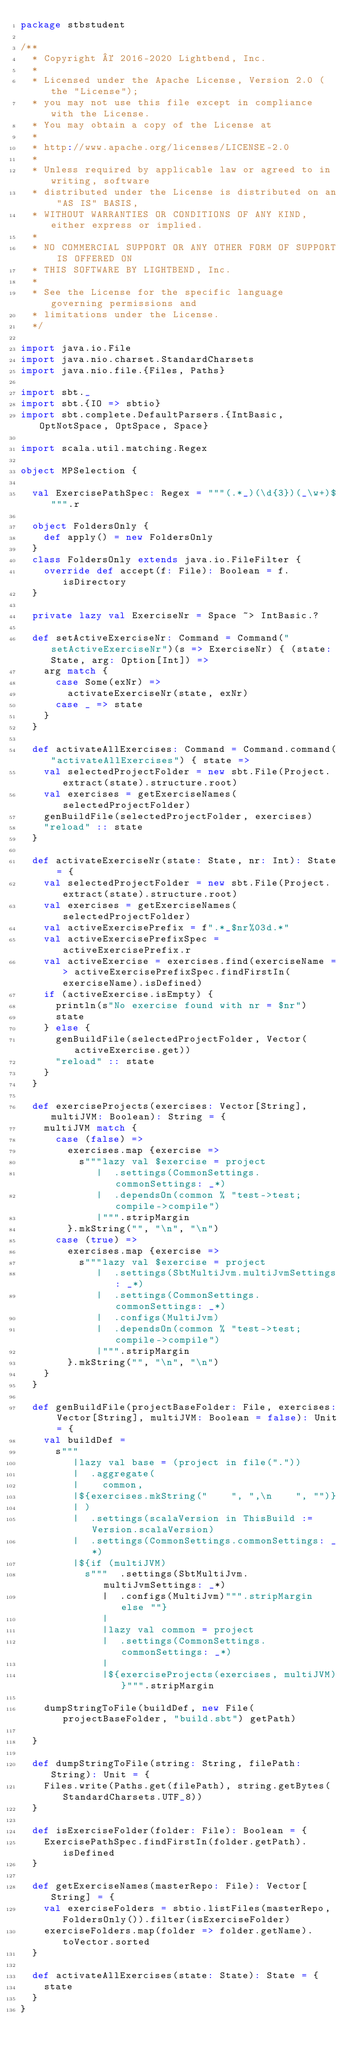<code> <loc_0><loc_0><loc_500><loc_500><_Scala_>package stbstudent

/**
  * Copyright © 2016-2020 Lightbend, Inc.
  *
  * Licensed under the Apache License, Version 2.0 (the "License");
  * you may not use this file except in compliance with the License.
  * You may obtain a copy of the License at
  *
  * http://www.apache.org/licenses/LICENSE-2.0
  *
  * Unless required by applicable law or agreed to in writing, software
  * distributed under the License is distributed on an "AS IS" BASIS,
  * WITHOUT WARRANTIES OR CONDITIONS OF ANY KIND, either express or implied.
  *
  * NO COMMERCIAL SUPPORT OR ANY OTHER FORM OF SUPPORT IS OFFERED ON
  * THIS SOFTWARE BY LIGHTBEND, Inc.
  *
  * See the License for the specific language governing permissions and
  * limitations under the License.
  */

import java.io.File
import java.nio.charset.StandardCharsets
import java.nio.file.{Files, Paths}

import sbt._
import sbt.{IO => sbtio}
import sbt.complete.DefaultParsers.{IntBasic, OptNotSpace, OptSpace, Space}

import scala.util.matching.Regex

object MPSelection {

  val ExercisePathSpec: Regex = """(.*_)(\d{3})(_\w+)$""".r

  object FoldersOnly {
    def apply() = new FoldersOnly
  }
  class FoldersOnly extends java.io.FileFilter {
    override def accept(f: File): Boolean = f.isDirectory
  }

  private lazy val ExerciseNr = Space ~> IntBasic.?

  def setActiveExerciseNr: Command = Command("setActiveExerciseNr")(s => ExerciseNr) { (state: State, arg: Option[Int]) =>
    arg match {
      case Some(exNr) =>
        activateExerciseNr(state, exNr)
      case _ => state
    }
  }

  def activateAllExercises: Command = Command.command("activateAllExercises") { state =>
    val selectedProjectFolder = new sbt.File(Project.extract(state).structure.root)
    val exercises = getExerciseNames(selectedProjectFolder)
    genBuildFile(selectedProjectFolder, exercises)
    "reload" :: state
  }

  def activateExerciseNr(state: State, nr: Int): State = {
    val selectedProjectFolder = new sbt.File(Project.extract(state).structure.root)
    val exercises = getExerciseNames(selectedProjectFolder)
    val activeExercisePrefix = f".*_$nr%03d.*"
    val activeExercisePrefixSpec = activeExercisePrefix.r
    val activeExercise = exercises.find(exerciseName => activeExercisePrefixSpec.findFirstIn(exerciseName).isDefined)
    if (activeExercise.isEmpty) {
      println(s"No exercise found with nr = $nr")
      state
    } else {
      genBuildFile(selectedProjectFolder, Vector(activeExercise.get))
      "reload" :: state
    }
  }

  def exerciseProjects(exercises: Vector[String], multiJVM: Boolean): String = {
    multiJVM match {
      case (false) =>
        exercises.map {exercise =>
          s"""lazy val $exercise = project
             |  .settings(CommonSettings.commonSettings: _*)
             |  .dependsOn(common % "test->test;compile->compile")
             |""".stripMargin
        }.mkString("", "\n", "\n")
      case (true) =>
        exercises.map {exercise =>
          s"""lazy val $exercise = project
             |  .settings(SbtMultiJvm.multiJvmSettings: _*)
             |  .settings(CommonSettings.commonSettings: _*)
             |  .configs(MultiJvm)
             |  .dependsOn(common % "test->test;compile->compile")
             |""".stripMargin
        }.mkString("", "\n", "\n")
    }
  }

  def genBuildFile(projectBaseFolder: File, exercises: Vector[String], multiJVM: Boolean = false): Unit = {
    val buildDef =
      s"""
         |lazy val base = (project in file("."))
         |  .aggregate(
         |    common,
         |${exercises.mkString("    ", ",\n    ", "")}
         | )
         |  .settings(scalaVersion in ThisBuild := Version.scalaVersion)
         |  .settings(CommonSettings.commonSettings: _*)
         |${if (multiJVM)
           s"""  .settings(SbtMultiJvm.multiJvmSettings: _*)
              |  .configs(MultiJvm)""".stripMargin else ""}
              |
              |lazy val common = project
              |  .settings(CommonSettings.commonSettings: _*)
              |
              |${exerciseProjects(exercises, multiJVM)}""".stripMargin

    dumpStringToFile(buildDef, new File(projectBaseFolder, "build.sbt") getPath)

  }

  def dumpStringToFile(string: String, filePath: String): Unit = {
    Files.write(Paths.get(filePath), string.getBytes(StandardCharsets.UTF_8))
  }

  def isExerciseFolder(folder: File): Boolean = {
    ExercisePathSpec.findFirstIn(folder.getPath).isDefined
  }

  def getExerciseNames(masterRepo: File): Vector[String] = {
    val exerciseFolders = sbtio.listFiles(masterRepo, FoldersOnly()).filter(isExerciseFolder)
    exerciseFolders.map(folder => folder.getName).toVector.sorted
  }

  def activateAllExercises(state: State): State = {
    state
  }
}
</code> 